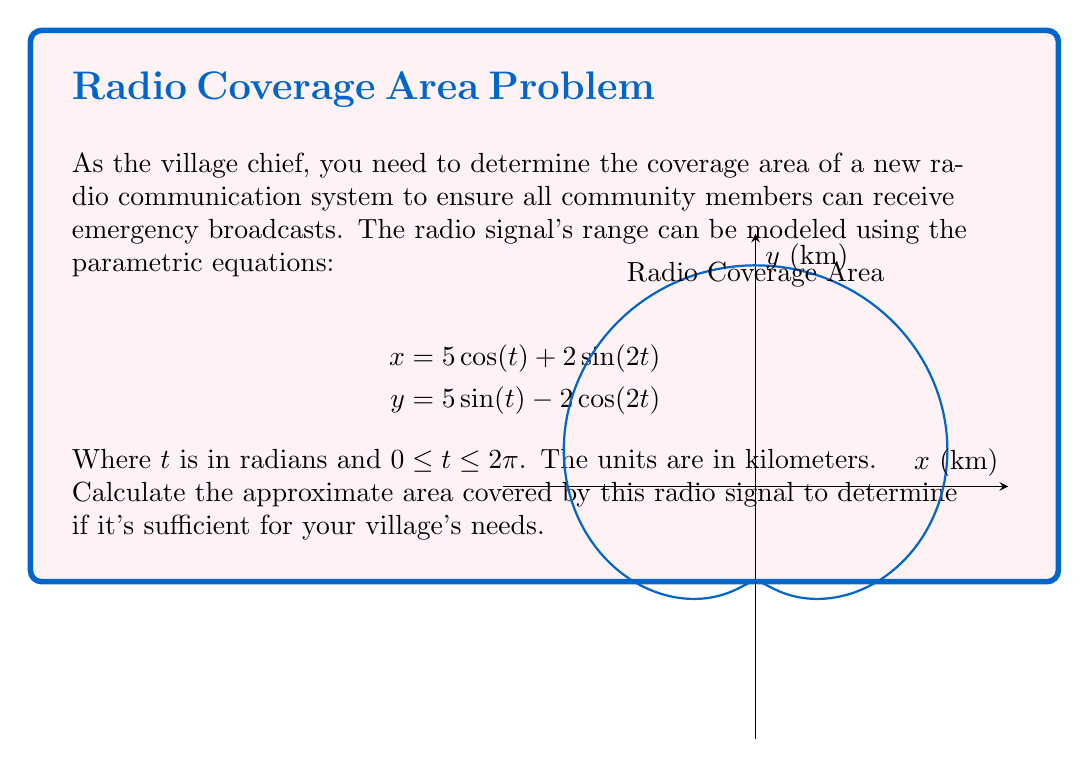Provide a solution to this math problem. To estimate the area covered by the radio signal, we can use Green's theorem, which relates a line integral around a closed curve to a double integral over the region enclosed by the curve.

1) The area enclosed by a parametric curve is given by:

   $$A = \frac{1}{2} \int_0^{2\pi} [x(t)\frac{dy}{dt} - y(t)\frac{dx}{dt}] dt$$

2) First, let's calculate $\frac{dx}{dt}$ and $\frac{dy}{dt}$:

   $$\frac{dx}{dt} = -5\sin(t) + 4\cos(2t)$$
   $$\frac{dy}{dt} = 5\cos(t) + 4\sin(2t)$$

3) Now, let's substitute these into our area formula:

   $$A = \frac{1}{2} \int_0^{2\pi} [(5\cos(t) + 2\sin(2t))(5\cos(t) + 4\sin(2t)) - (5\sin(t) - 2\cos(2t))(-5\sin(t) + 4\cos(2t))] dt$$

4) Expanding this:

   $$A = \frac{1}{2} \int_0^{2\pi} [25\cos^2(t) + 20\cos(t)\sin(2t) + 10\sin(2t)\cos(t) + 8\sin^2(2t) + 25\sin^2(t) - 20\sin(t)\cos(2t) - 10\cos(2t)\sin(t) + 8\cos^2(2t)] dt$$

5) Simplifying using trigonometric identities:

   $$A = \frac{1}{2} \int_0^{2\pi} [25 + 30\sin(2t)\cos(t) - 30\sin(t)\cos(2t) + 8] dt$$

6) Further simplification:

   $$A = \frac{1}{2} \int_0^{2\pi} 33 dt = \frac{33}{2} \cdot 2\pi = 33\pi$$

Therefore, the area covered by the radio signal is approximately 103.67 square kilometers.
Answer: $33\pi$ square kilometers (≈ 103.67 km²) 